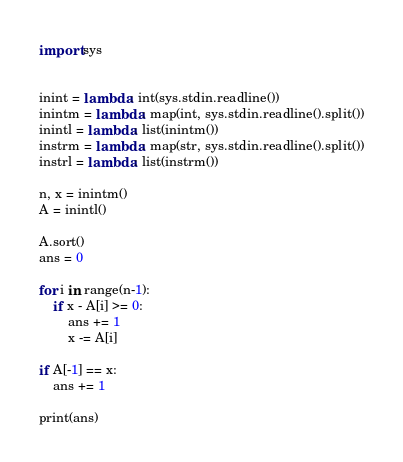Convert code to text. <code><loc_0><loc_0><loc_500><loc_500><_Python_>import sys


inint = lambda: int(sys.stdin.readline())
inintm = lambda: map(int, sys.stdin.readline().split())
inintl = lambda: list(inintm())
instrm = lambda: map(str, sys.stdin.readline().split())
instrl = lambda: list(instrm())

n, x = inintm()
A = inintl()

A.sort()
ans = 0

for i in range(n-1):
    if x - A[i] >= 0:
        ans += 1
        x -= A[i]

if A[-1] == x:
    ans += 1

print(ans)
</code> 